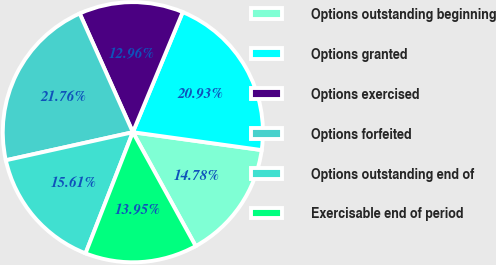Convert chart. <chart><loc_0><loc_0><loc_500><loc_500><pie_chart><fcel>Options outstanding beginning<fcel>Options granted<fcel>Options exercised<fcel>Options forfeited<fcel>Options outstanding end of<fcel>Exercisable end of period<nl><fcel>14.78%<fcel>20.93%<fcel>12.96%<fcel>21.76%<fcel>15.61%<fcel>13.95%<nl></chart> 